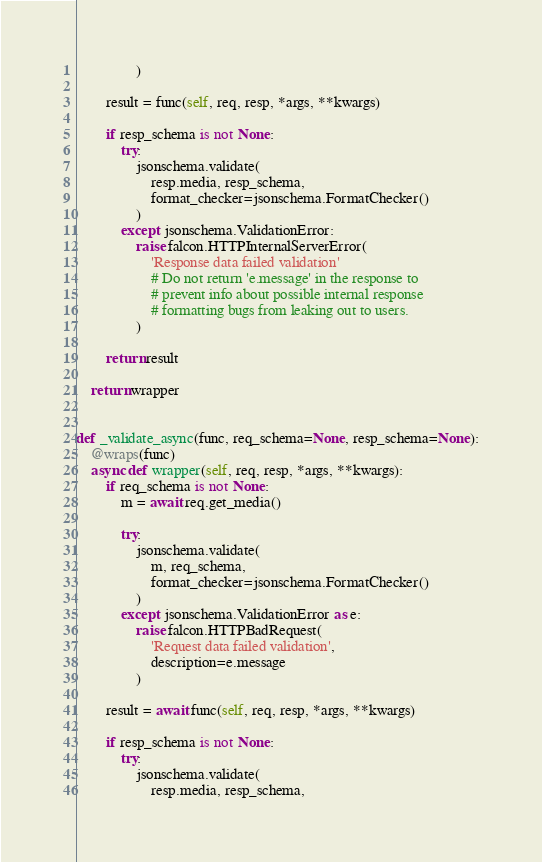Convert code to text. <code><loc_0><loc_0><loc_500><loc_500><_Python_>                )

        result = func(self, req, resp, *args, **kwargs)

        if resp_schema is not None:
            try:
                jsonschema.validate(
                    resp.media, resp_schema,
                    format_checker=jsonschema.FormatChecker()
                )
            except jsonschema.ValidationError:
                raise falcon.HTTPInternalServerError(
                    'Response data failed validation'
                    # Do not return 'e.message' in the response to
                    # prevent info about possible internal response
                    # formatting bugs from leaking out to users.
                )

        return result

    return wrapper


def _validate_async(func, req_schema=None, resp_schema=None):
    @wraps(func)
    async def wrapper(self, req, resp, *args, **kwargs):
        if req_schema is not None:
            m = await req.get_media()

            try:
                jsonschema.validate(
                    m, req_schema,
                    format_checker=jsonschema.FormatChecker()
                )
            except jsonschema.ValidationError as e:
                raise falcon.HTTPBadRequest(
                    'Request data failed validation',
                    description=e.message
                )

        result = await func(self, req, resp, *args, **kwargs)

        if resp_schema is not None:
            try:
                jsonschema.validate(
                    resp.media, resp_schema,</code> 